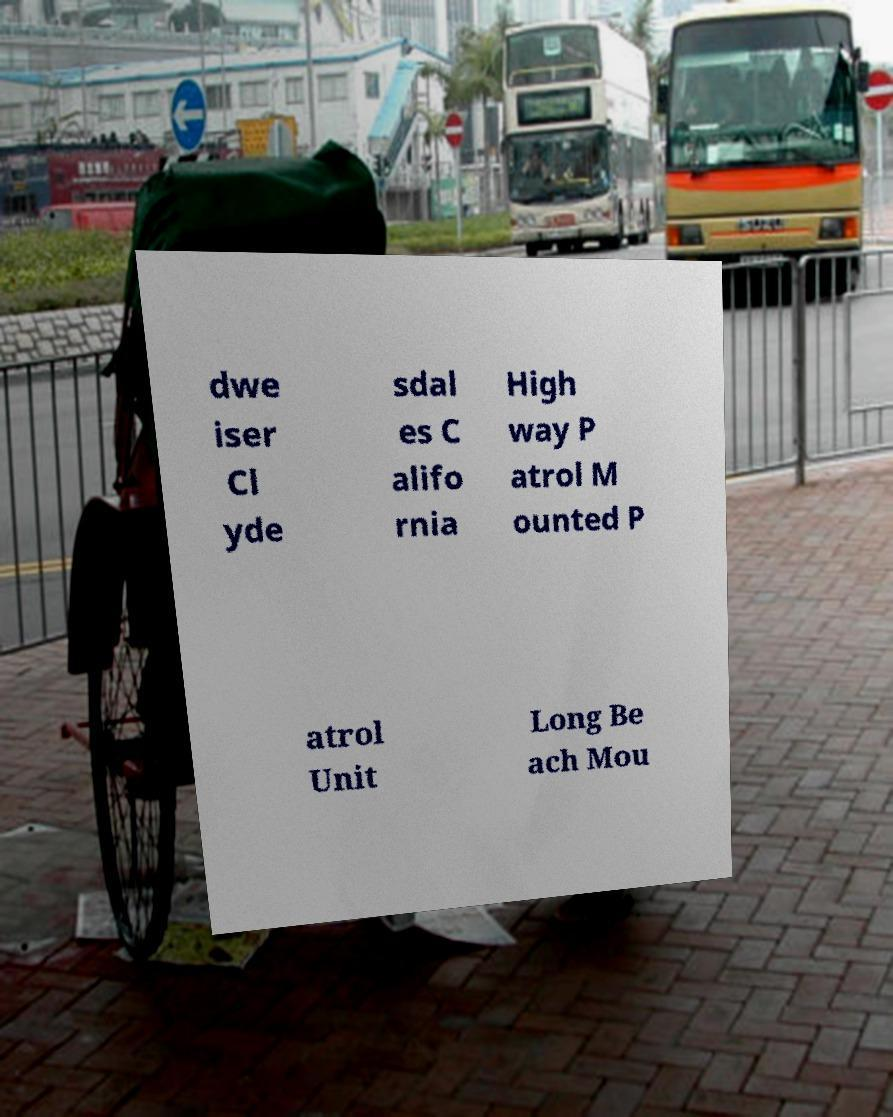I need the written content from this picture converted into text. Can you do that? dwe iser Cl yde sdal es C alifo rnia High way P atrol M ounted P atrol Unit Long Be ach Mou 